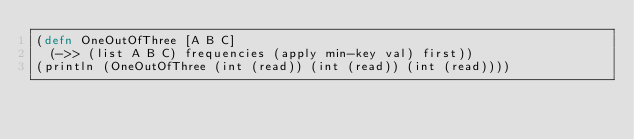Convert code to text. <code><loc_0><loc_0><loc_500><loc_500><_Clojure_>(defn OneOutOfThree [A B C]
  (->> (list A B C) frequencies (apply min-key val) first))
(println (OneOutOfThree (int (read)) (int (read)) (int (read))))</code> 